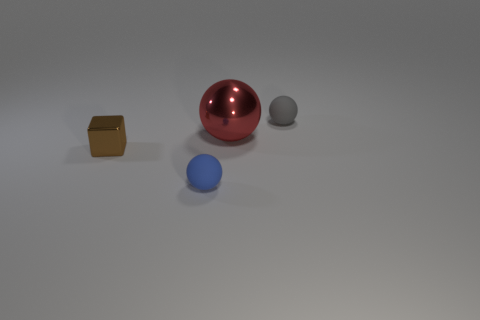Add 3 tiny gray rubber spheres. How many objects exist? 7 Subtract all spheres. How many objects are left? 1 Subtract all shiny balls. Subtract all large yellow balls. How many objects are left? 3 Add 4 large red metallic things. How many large red metallic things are left? 5 Add 3 big red metallic spheres. How many big red metallic spheres exist? 4 Subtract 1 red spheres. How many objects are left? 3 